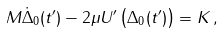<formula> <loc_0><loc_0><loc_500><loc_500>M \dot { \Delta } _ { 0 } ( t ^ { \prime } ) - 2 \mu U ^ { \prime } \left ( \Delta _ { 0 } ( t ^ { \prime } ) \right ) = K \, ,</formula> 